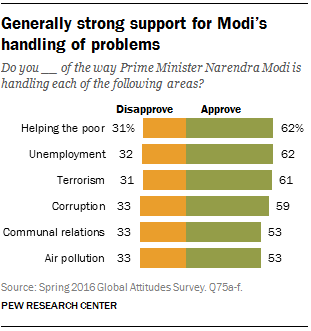Highlight a few significant elements in this photo. Approximately 61% of people approve of terrorism. I'm not sure I understand the question. Could you please provide more context or clarify what you are asking? 